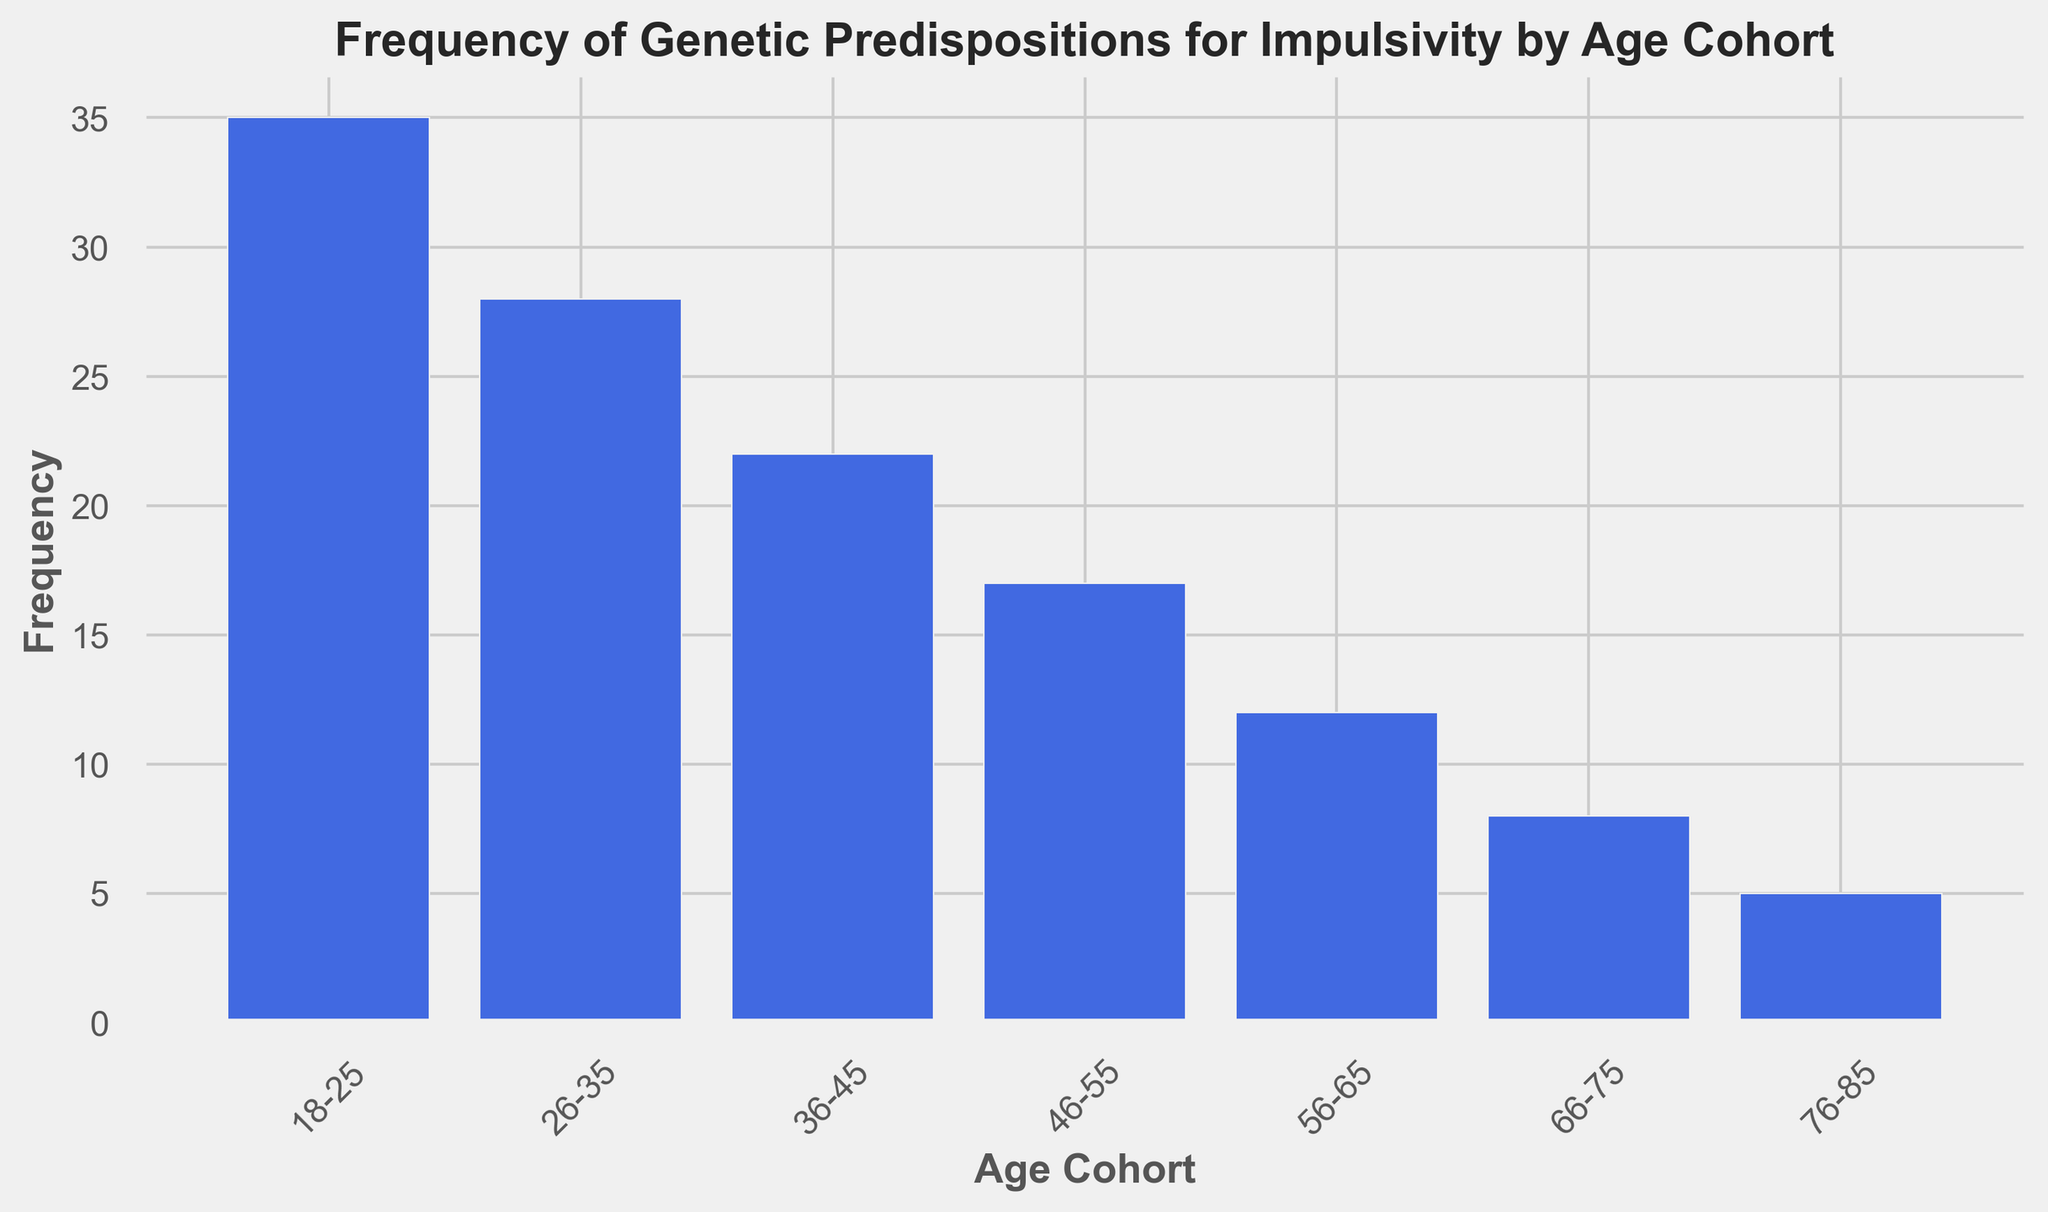Which age cohort has the highest frequency of genetic predispositions for impulsivity? The bar for the 18-25 age cohort is the tallest, indicating that this age group has the highest frequency.
Answer: 18-25 Which age cohort has the lowest frequency of genetic predispositions for impulsivity? The bar for the 76-85 age cohort is the shortest, indicating that this age group has the lowest frequency.
Answer: 76-85 What is the difference between the highest and lowest frequencies of genetic predispositions for impulsivity among the age cohorts? The highest frequency is 35 (18-25 age cohort), and the lowest is 5 (76-85 age cohort). The difference is 35 - 5 = 30.
Answer: 30 How does the frequency of genetic predispositions for impulsivity change as age increases? The height of the bars decreases as the age cohorts increase from 18-25 to 76-85, indicating a general decline in frequency.
Answer: Decreases What is the total frequency of genetic predispositions for impulsivity for the cohorts below 36 years old? Sum the frequencies for the 18-25 and 26-35 age cohorts: 35 + 28 = 63.
Answer: 63 Which age cohort has a frequency closest to the midpoint between the highest and lowest frequencies? The midpoint between the highest (35) and lowest (5) frequencies is (35 + 5) / 2 = 20. The closest age cohort frequency to 20 is 22 (36-45 age cohort).
Answer: 36-45 Is the frequency of genetic predispositions for impulsivity in the 46-55 age cohort higher or lower than that of the 56-65 age cohort? The frequency for the 46-55 age cohort (17) is higher than that of the 56-65 age cohort (12).
Answer: Higher What is the average frequency of genetic predispositions for impulsivity across all age cohorts? Sum all the frequencies (35 + 28 + 22 + 17 + 12 + 8 + 5 = 127) and divide by the number of cohorts (7): 127 / 7 ≈ 18.14.
Answer: 18.14 How many age cohorts have a frequency of genetic predispositions for impulsivity greater than 20? The cohorts with frequencies greater than 20 are 18-25 (35), 26-35 (28), and 36-45 (22). There are 3 such cohorts.
Answer: 3 